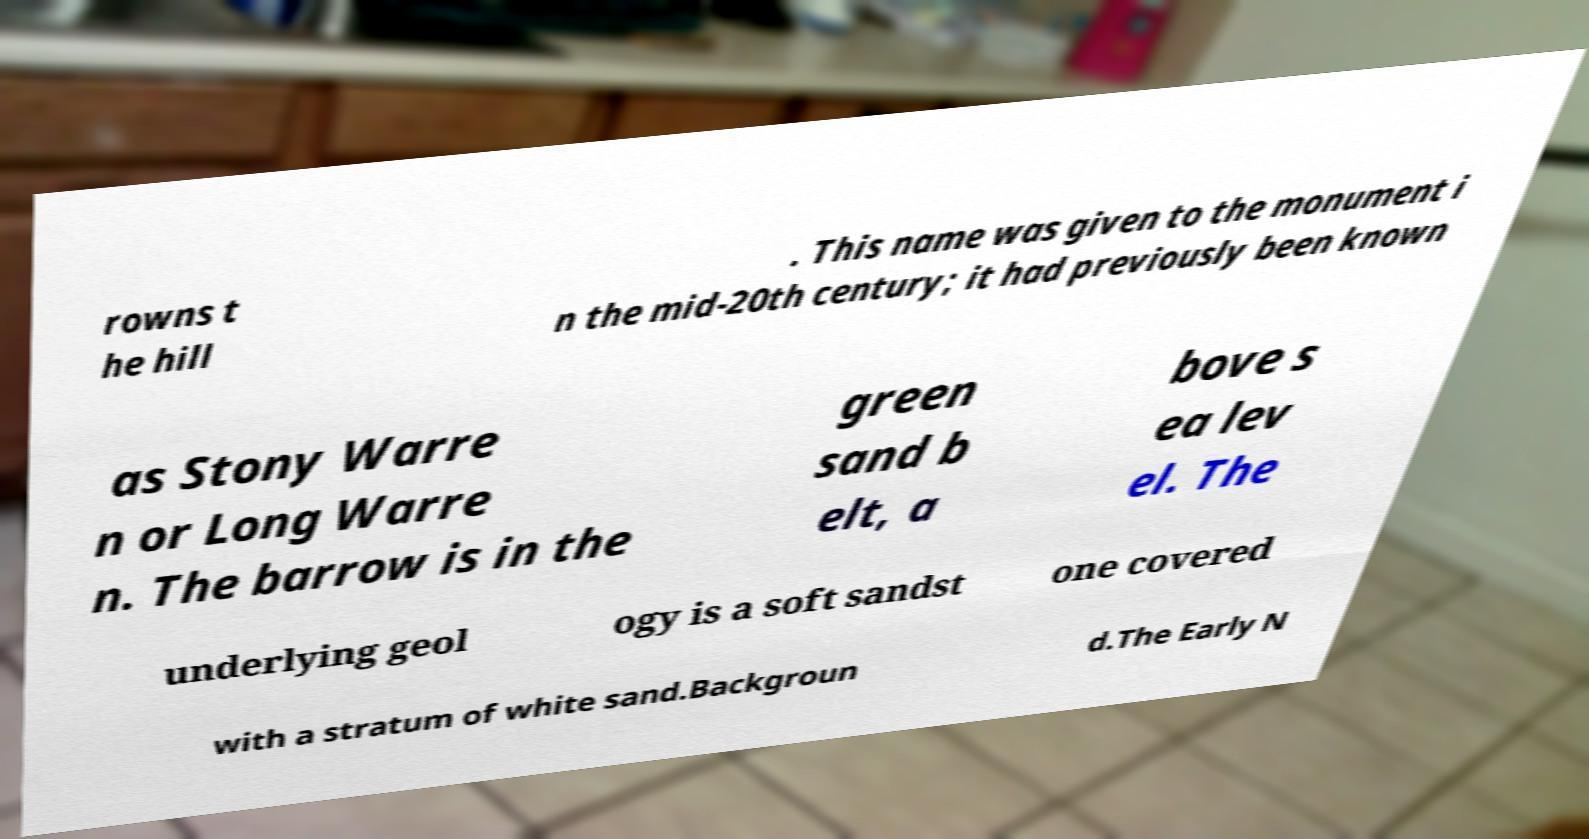Could you extract and type out the text from this image? rowns t he hill . This name was given to the monument i n the mid-20th century; it had previously been known as Stony Warre n or Long Warre n. The barrow is in the green sand b elt, a bove s ea lev el. The underlying geol ogy is a soft sandst one covered with a stratum of white sand.Backgroun d.The Early N 